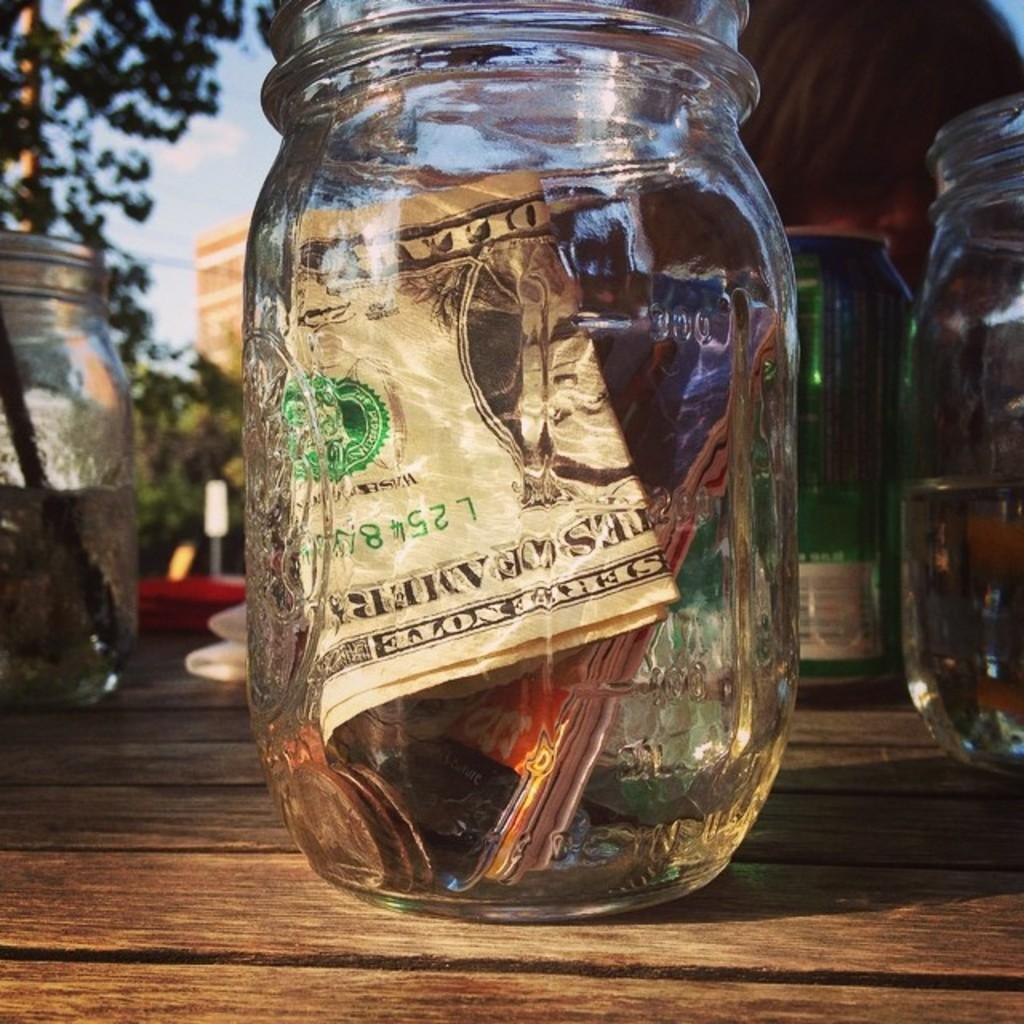What objects are on the table in the image? There are jars and a tin on the table. Is there anything specific about one of the jars on the table? Yes, there is a jar containing money in the center of the table. What can be seen in the background of the image? There is a building, a tree, and the sky visible in the background of the image. What type of rifle is being used by the organization in the image? There is no rifle or organization present in the image. Is there any indication of an upcoming trip in the image? There is no indication of a trip in the image. 